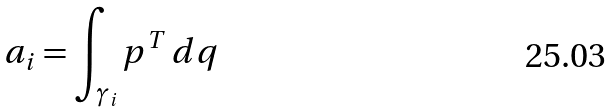<formula> <loc_0><loc_0><loc_500><loc_500>a _ { i } = \int _ { \gamma _ { i } } p ^ { T } \, d q</formula> 